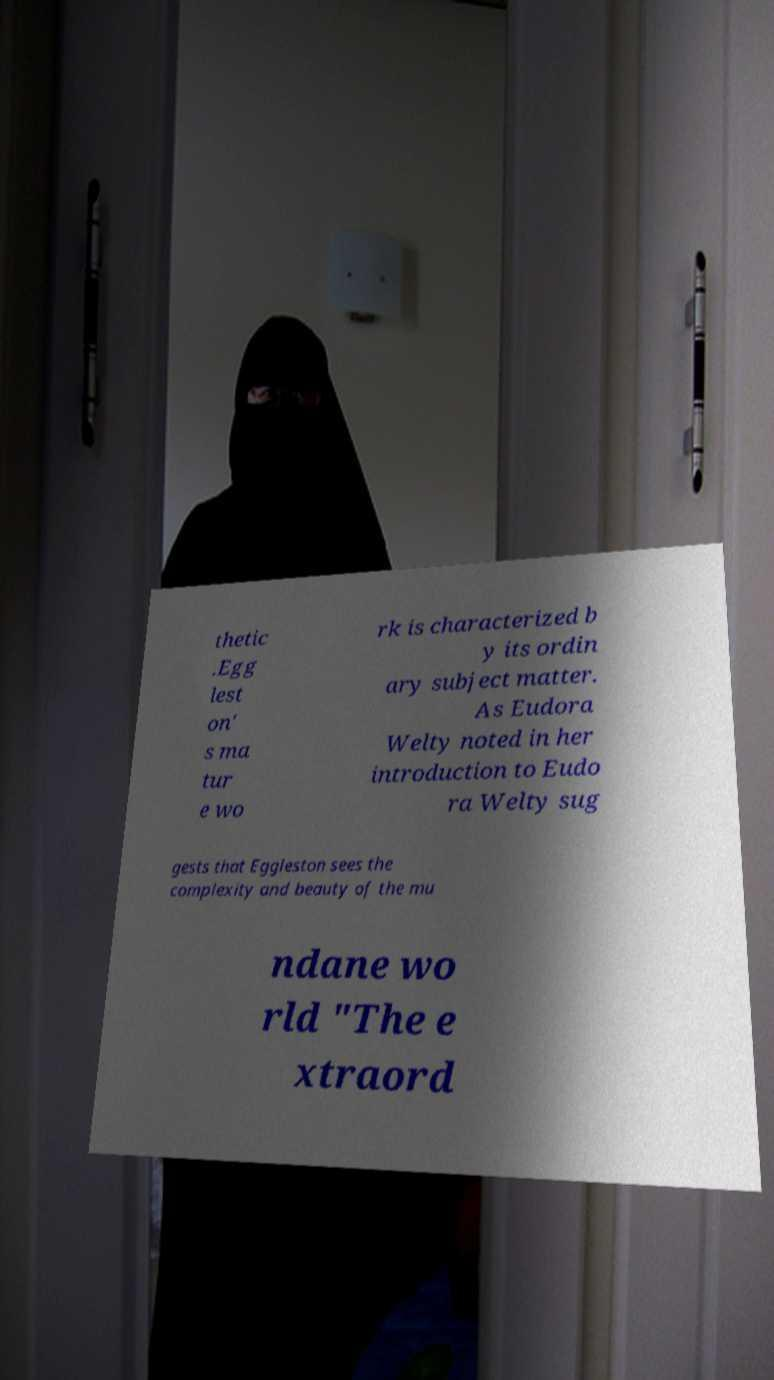What messages or text are displayed in this image? I need them in a readable, typed format. thetic .Egg lest on' s ma tur e wo rk is characterized b y its ordin ary subject matter. As Eudora Welty noted in her introduction to Eudo ra Welty sug gests that Eggleston sees the complexity and beauty of the mu ndane wo rld "The e xtraord 